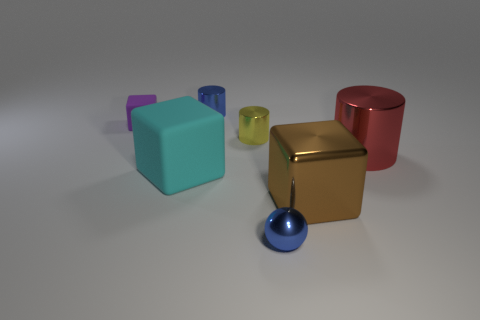Do the small thing that is in front of the brown metallic object and the tiny metallic object that is behind the tiny purple rubber block have the same color?
Offer a terse response. Yes. Is there a small metallic object of the same color as the metallic ball?
Make the answer very short. Yes. There is a blue metal thing in front of the big cube that is on the left side of the blue metallic object in front of the tiny blue cylinder; what is its size?
Make the answer very short. Small. Is there a big thing that has the same material as the small yellow object?
Keep it short and to the point. Yes. What is the shape of the cyan matte thing?
Make the answer very short. Cube. The big cylinder that is the same material as the tiny blue sphere is what color?
Make the answer very short. Red. How many red objects are either large metallic things or tiny cylinders?
Keep it short and to the point. 1. Are there more big cyan rubber cubes than cubes?
Offer a very short reply. No. How many objects are either blue objects that are to the left of the blue metal sphere or cylinders that are on the right side of the metallic sphere?
Your response must be concise. 2. There is a cylinder that is the same size as the cyan matte object; what color is it?
Your answer should be compact. Red. 